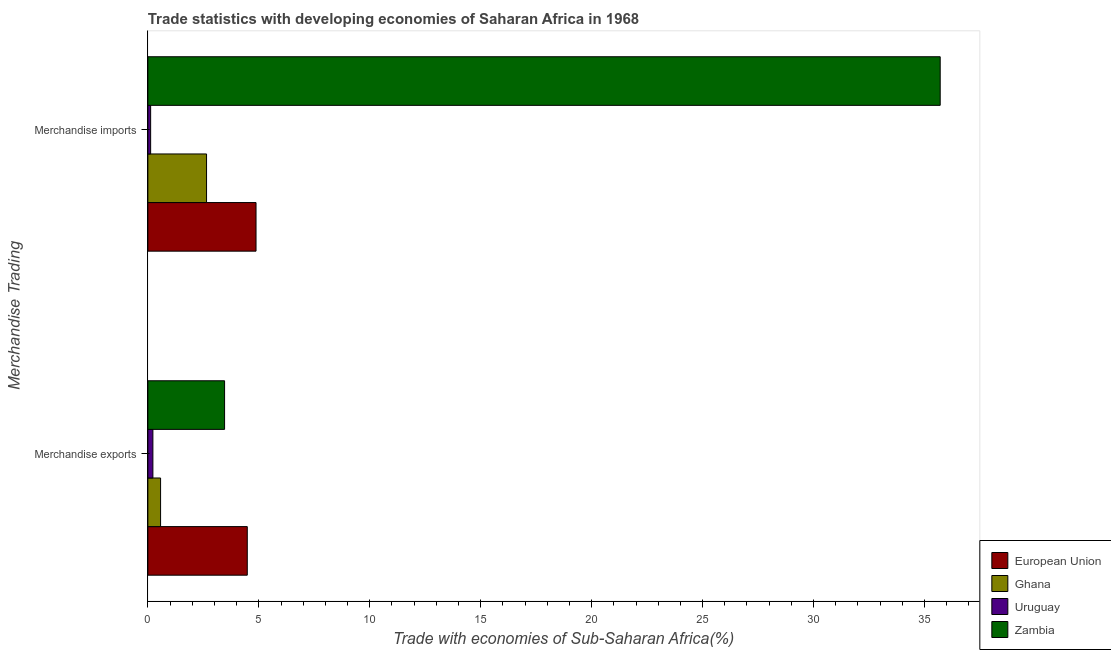How many different coloured bars are there?
Give a very brief answer. 4. How many groups of bars are there?
Make the answer very short. 2. Are the number of bars per tick equal to the number of legend labels?
Make the answer very short. Yes. Are the number of bars on each tick of the Y-axis equal?
Make the answer very short. Yes. How many bars are there on the 2nd tick from the top?
Make the answer very short. 4. How many bars are there on the 2nd tick from the bottom?
Your answer should be compact. 4. What is the label of the 2nd group of bars from the top?
Offer a terse response. Merchandise exports. What is the merchandise imports in European Union?
Keep it short and to the point. 4.87. Across all countries, what is the maximum merchandise imports?
Keep it short and to the point. 35.71. Across all countries, what is the minimum merchandise exports?
Provide a succinct answer. 0.23. In which country was the merchandise imports minimum?
Your response must be concise. Uruguay. What is the total merchandise imports in the graph?
Your answer should be compact. 43.35. What is the difference between the merchandise imports in European Union and that in Zambia?
Your answer should be compact. -30.83. What is the difference between the merchandise exports in European Union and the merchandise imports in Uruguay?
Your response must be concise. 4.36. What is the average merchandise imports per country?
Your response must be concise. 10.84. What is the difference between the merchandise imports and merchandise exports in Ghana?
Your response must be concise. 2.07. What is the ratio of the merchandise exports in Uruguay to that in Zambia?
Ensure brevity in your answer.  0.07. Is the merchandise exports in European Union less than that in Ghana?
Your answer should be very brief. No. What does the 1st bar from the bottom in Merchandise exports represents?
Keep it short and to the point. European Union. How many countries are there in the graph?
Ensure brevity in your answer.  4. Are the values on the major ticks of X-axis written in scientific E-notation?
Provide a succinct answer. No. Does the graph contain any zero values?
Give a very brief answer. No. How are the legend labels stacked?
Provide a succinct answer. Vertical. What is the title of the graph?
Provide a succinct answer. Trade statistics with developing economies of Saharan Africa in 1968. Does "Luxembourg" appear as one of the legend labels in the graph?
Ensure brevity in your answer.  No. What is the label or title of the X-axis?
Provide a succinct answer. Trade with economies of Sub-Saharan Africa(%). What is the label or title of the Y-axis?
Provide a succinct answer. Merchandise Trading. What is the Trade with economies of Sub-Saharan Africa(%) of European Union in Merchandise exports?
Give a very brief answer. 4.48. What is the Trade with economies of Sub-Saharan Africa(%) in Ghana in Merchandise exports?
Your answer should be very brief. 0.57. What is the Trade with economies of Sub-Saharan Africa(%) of Uruguay in Merchandise exports?
Provide a short and direct response. 0.23. What is the Trade with economies of Sub-Saharan Africa(%) in Zambia in Merchandise exports?
Keep it short and to the point. 3.46. What is the Trade with economies of Sub-Saharan Africa(%) in European Union in Merchandise imports?
Offer a very short reply. 4.87. What is the Trade with economies of Sub-Saharan Africa(%) of Ghana in Merchandise imports?
Keep it short and to the point. 2.64. What is the Trade with economies of Sub-Saharan Africa(%) of Uruguay in Merchandise imports?
Give a very brief answer. 0.13. What is the Trade with economies of Sub-Saharan Africa(%) in Zambia in Merchandise imports?
Your answer should be very brief. 35.71. Across all Merchandise Trading, what is the maximum Trade with economies of Sub-Saharan Africa(%) in European Union?
Your answer should be very brief. 4.87. Across all Merchandise Trading, what is the maximum Trade with economies of Sub-Saharan Africa(%) of Ghana?
Your answer should be compact. 2.64. Across all Merchandise Trading, what is the maximum Trade with economies of Sub-Saharan Africa(%) of Uruguay?
Make the answer very short. 0.23. Across all Merchandise Trading, what is the maximum Trade with economies of Sub-Saharan Africa(%) in Zambia?
Provide a short and direct response. 35.71. Across all Merchandise Trading, what is the minimum Trade with economies of Sub-Saharan Africa(%) in European Union?
Your response must be concise. 4.48. Across all Merchandise Trading, what is the minimum Trade with economies of Sub-Saharan Africa(%) in Ghana?
Provide a succinct answer. 0.57. Across all Merchandise Trading, what is the minimum Trade with economies of Sub-Saharan Africa(%) in Uruguay?
Make the answer very short. 0.13. Across all Merchandise Trading, what is the minimum Trade with economies of Sub-Saharan Africa(%) of Zambia?
Your answer should be very brief. 3.46. What is the total Trade with economies of Sub-Saharan Africa(%) in European Union in the graph?
Keep it short and to the point. 9.35. What is the total Trade with economies of Sub-Saharan Africa(%) in Ghana in the graph?
Make the answer very short. 3.22. What is the total Trade with economies of Sub-Saharan Africa(%) in Uruguay in the graph?
Your answer should be very brief. 0.35. What is the total Trade with economies of Sub-Saharan Africa(%) in Zambia in the graph?
Provide a short and direct response. 39.17. What is the difference between the Trade with economies of Sub-Saharan Africa(%) of European Union in Merchandise exports and that in Merchandise imports?
Offer a very short reply. -0.39. What is the difference between the Trade with economies of Sub-Saharan Africa(%) in Ghana in Merchandise exports and that in Merchandise imports?
Your response must be concise. -2.07. What is the difference between the Trade with economies of Sub-Saharan Africa(%) of Uruguay in Merchandise exports and that in Merchandise imports?
Your answer should be compact. 0.1. What is the difference between the Trade with economies of Sub-Saharan Africa(%) of Zambia in Merchandise exports and that in Merchandise imports?
Offer a terse response. -32.25. What is the difference between the Trade with economies of Sub-Saharan Africa(%) of European Union in Merchandise exports and the Trade with economies of Sub-Saharan Africa(%) of Ghana in Merchandise imports?
Provide a short and direct response. 1.84. What is the difference between the Trade with economies of Sub-Saharan Africa(%) in European Union in Merchandise exports and the Trade with economies of Sub-Saharan Africa(%) in Uruguay in Merchandise imports?
Offer a terse response. 4.36. What is the difference between the Trade with economies of Sub-Saharan Africa(%) of European Union in Merchandise exports and the Trade with economies of Sub-Saharan Africa(%) of Zambia in Merchandise imports?
Your response must be concise. -31.23. What is the difference between the Trade with economies of Sub-Saharan Africa(%) of Ghana in Merchandise exports and the Trade with economies of Sub-Saharan Africa(%) of Uruguay in Merchandise imports?
Provide a succinct answer. 0.45. What is the difference between the Trade with economies of Sub-Saharan Africa(%) in Ghana in Merchandise exports and the Trade with economies of Sub-Saharan Africa(%) in Zambia in Merchandise imports?
Give a very brief answer. -35.13. What is the difference between the Trade with economies of Sub-Saharan Africa(%) in Uruguay in Merchandise exports and the Trade with economies of Sub-Saharan Africa(%) in Zambia in Merchandise imports?
Your answer should be very brief. -35.48. What is the average Trade with economies of Sub-Saharan Africa(%) in European Union per Merchandise Trading?
Your answer should be very brief. 4.68. What is the average Trade with economies of Sub-Saharan Africa(%) in Ghana per Merchandise Trading?
Your answer should be compact. 1.61. What is the average Trade with economies of Sub-Saharan Africa(%) of Uruguay per Merchandise Trading?
Offer a terse response. 0.18. What is the average Trade with economies of Sub-Saharan Africa(%) of Zambia per Merchandise Trading?
Provide a succinct answer. 19.58. What is the difference between the Trade with economies of Sub-Saharan Africa(%) of European Union and Trade with economies of Sub-Saharan Africa(%) of Ghana in Merchandise exports?
Provide a short and direct response. 3.91. What is the difference between the Trade with economies of Sub-Saharan Africa(%) of European Union and Trade with economies of Sub-Saharan Africa(%) of Uruguay in Merchandise exports?
Your answer should be compact. 4.25. What is the difference between the Trade with economies of Sub-Saharan Africa(%) of European Union and Trade with economies of Sub-Saharan Africa(%) of Zambia in Merchandise exports?
Your response must be concise. 1.02. What is the difference between the Trade with economies of Sub-Saharan Africa(%) of Ghana and Trade with economies of Sub-Saharan Africa(%) of Uruguay in Merchandise exports?
Keep it short and to the point. 0.35. What is the difference between the Trade with economies of Sub-Saharan Africa(%) in Ghana and Trade with economies of Sub-Saharan Africa(%) in Zambia in Merchandise exports?
Provide a succinct answer. -2.88. What is the difference between the Trade with economies of Sub-Saharan Africa(%) in Uruguay and Trade with economies of Sub-Saharan Africa(%) in Zambia in Merchandise exports?
Provide a short and direct response. -3.23. What is the difference between the Trade with economies of Sub-Saharan Africa(%) of European Union and Trade with economies of Sub-Saharan Africa(%) of Ghana in Merchandise imports?
Your answer should be very brief. 2.23. What is the difference between the Trade with economies of Sub-Saharan Africa(%) of European Union and Trade with economies of Sub-Saharan Africa(%) of Uruguay in Merchandise imports?
Offer a very short reply. 4.75. What is the difference between the Trade with economies of Sub-Saharan Africa(%) of European Union and Trade with economies of Sub-Saharan Africa(%) of Zambia in Merchandise imports?
Keep it short and to the point. -30.83. What is the difference between the Trade with economies of Sub-Saharan Africa(%) of Ghana and Trade with economies of Sub-Saharan Africa(%) of Uruguay in Merchandise imports?
Offer a very short reply. 2.52. What is the difference between the Trade with economies of Sub-Saharan Africa(%) of Ghana and Trade with economies of Sub-Saharan Africa(%) of Zambia in Merchandise imports?
Provide a short and direct response. -33.06. What is the difference between the Trade with economies of Sub-Saharan Africa(%) in Uruguay and Trade with economies of Sub-Saharan Africa(%) in Zambia in Merchandise imports?
Offer a very short reply. -35.58. What is the ratio of the Trade with economies of Sub-Saharan Africa(%) of European Union in Merchandise exports to that in Merchandise imports?
Provide a short and direct response. 0.92. What is the ratio of the Trade with economies of Sub-Saharan Africa(%) of Ghana in Merchandise exports to that in Merchandise imports?
Keep it short and to the point. 0.22. What is the ratio of the Trade with economies of Sub-Saharan Africa(%) of Uruguay in Merchandise exports to that in Merchandise imports?
Ensure brevity in your answer.  1.81. What is the ratio of the Trade with economies of Sub-Saharan Africa(%) in Zambia in Merchandise exports to that in Merchandise imports?
Offer a very short reply. 0.1. What is the difference between the highest and the second highest Trade with economies of Sub-Saharan Africa(%) of European Union?
Your answer should be very brief. 0.39. What is the difference between the highest and the second highest Trade with economies of Sub-Saharan Africa(%) of Ghana?
Make the answer very short. 2.07. What is the difference between the highest and the second highest Trade with economies of Sub-Saharan Africa(%) of Uruguay?
Make the answer very short. 0.1. What is the difference between the highest and the second highest Trade with economies of Sub-Saharan Africa(%) of Zambia?
Provide a succinct answer. 32.25. What is the difference between the highest and the lowest Trade with economies of Sub-Saharan Africa(%) in European Union?
Ensure brevity in your answer.  0.39. What is the difference between the highest and the lowest Trade with economies of Sub-Saharan Africa(%) of Ghana?
Offer a terse response. 2.07. What is the difference between the highest and the lowest Trade with economies of Sub-Saharan Africa(%) in Uruguay?
Make the answer very short. 0.1. What is the difference between the highest and the lowest Trade with economies of Sub-Saharan Africa(%) in Zambia?
Your response must be concise. 32.25. 